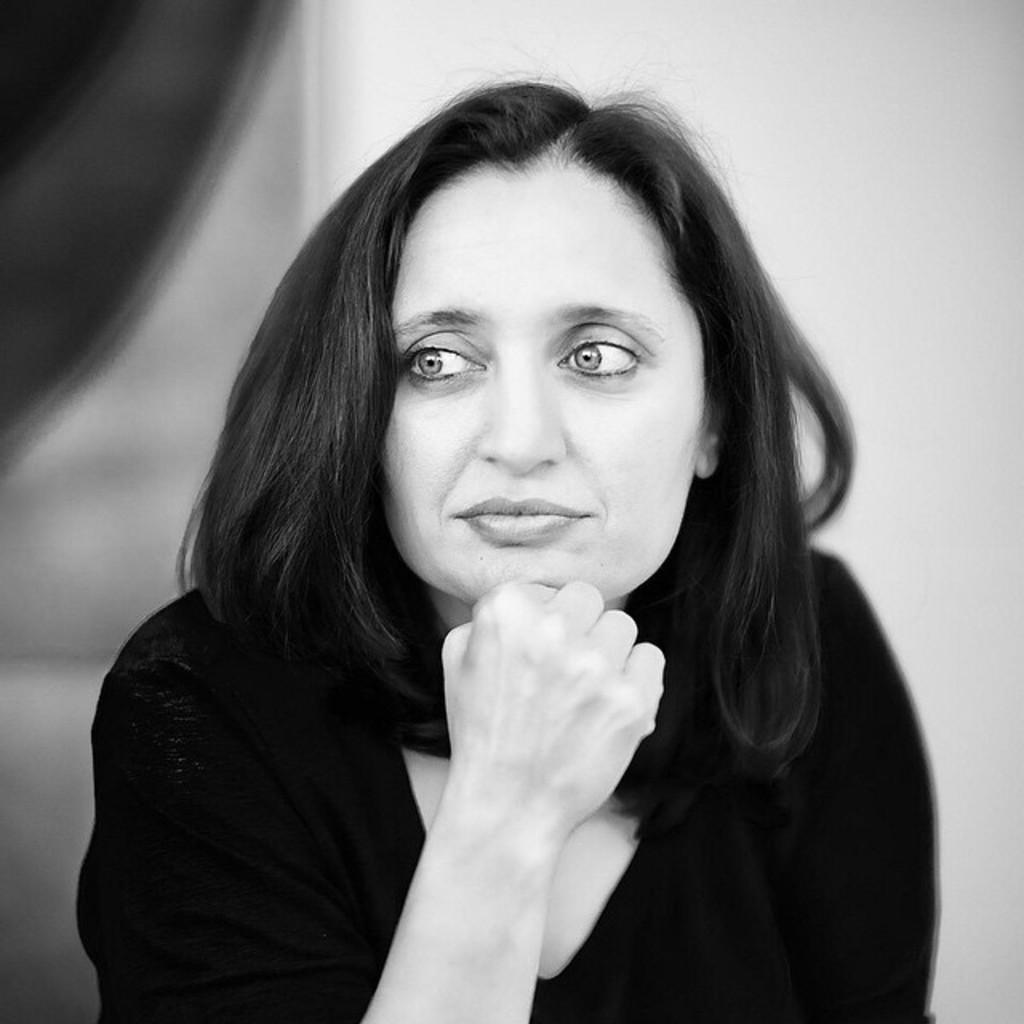Describe this image in one or two sentences. This is a black and white image. In the center of the image a lady is there. In the background of the image we can see the wall. 